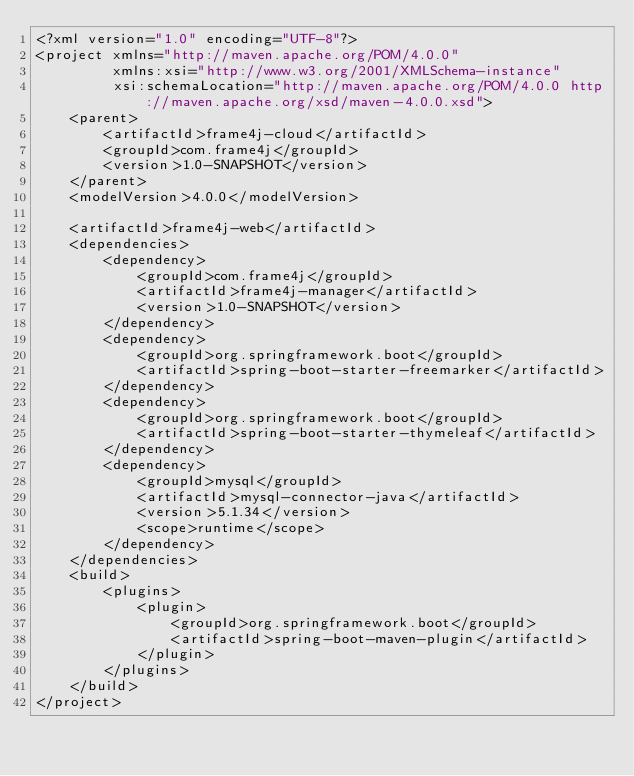<code> <loc_0><loc_0><loc_500><loc_500><_XML_><?xml version="1.0" encoding="UTF-8"?>
<project xmlns="http://maven.apache.org/POM/4.0.0"
         xmlns:xsi="http://www.w3.org/2001/XMLSchema-instance"
         xsi:schemaLocation="http://maven.apache.org/POM/4.0.0 http://maven.apache.org/xsd/maven-4.0.0.xsd">
    <parent>
        <artifactId>frame4j-cloud</artifactId>
        <groupId>com.frame4j</groupId>
        <version>1.0-SNAPSHOT</version>
    </parent>
    <modelVersion>4.0.0</modelVersion>

    <artifactId>frame4j-web</artifactId>
    <dependencies>
        <dependency>
            <groupId>com.frame4j</groupId>
            <artifactId>frame4j-manager</artifactId>
            <version>1.0-SNAPSHOT</version>
        </dependency>
        <dependency>
            <groupId>org.springframework.boot</groupId>
            <artifactId>spring-boot-starter-freemarker</artifactId>
        </dependency>
        <dependency>
            <groupId>org.springframework.boot</groupId>
            <artifactId>spring-boot-starter-thymeleaf</artifactId>
        </dependency>
        <dependency>
            <groupId>mysql</groupId>
            <artifactId>mysql-connector-java</artifactId>
            <version>5.1.34</version>
            <scope>runtime</scope>
        </dependency>
    </dependencies>
    <build>
        <plugins>
            <plugin>
                <groupId>org.springframework.boot</groupId>
                <artifactId>spring-boot-maven-plugin</artifactId>
            </plugin>
        </plugins>
    </build>
</project></code> 